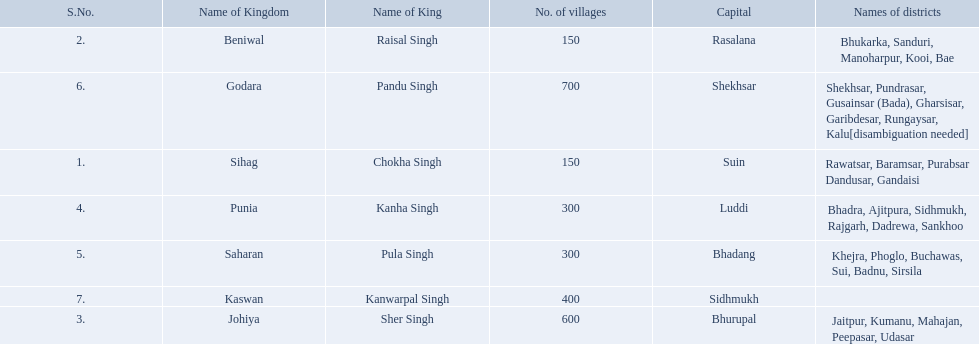What is the most amount of villages in a kingdom? 700. What is the second most amount of villages in a kingdom? 600. What kingdom has 600 villages? Johiya. 